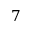Convert formula to latex. <formula><loc_0><loc_0><loc_500><loc_500>7</formula> 